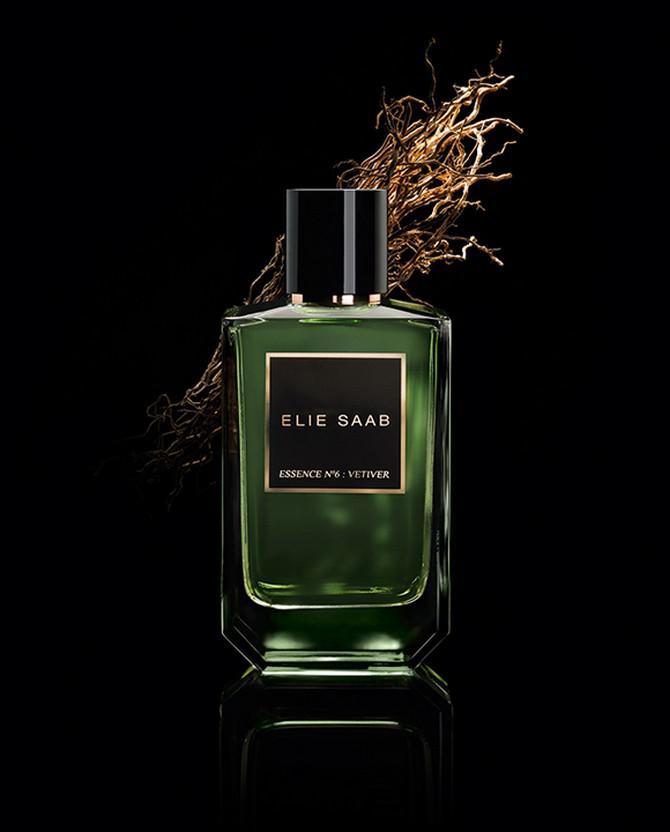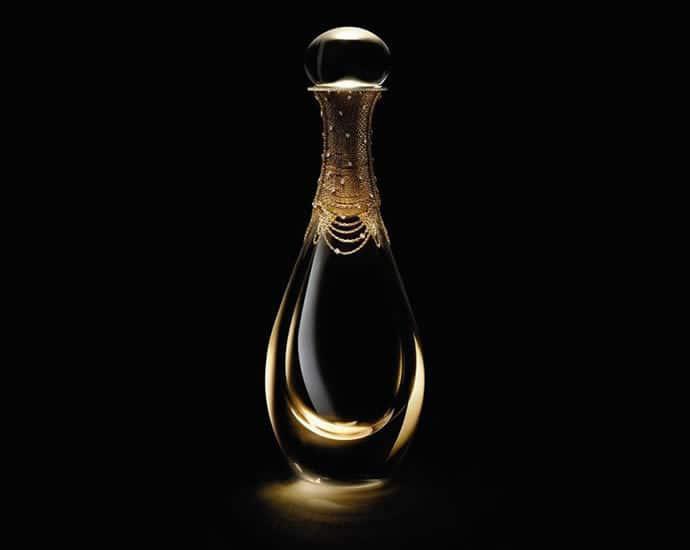The first image is the image on the left, the second image is the image on the right. For the images shown, is this caption "There are more than two perfume bottles." true? Answer yes or no. No. The first image is the image on the left, the second image is the image on the right. Examine the images to the left and right. Is the description "An image includes a fragrance bottle with a rounded base ad round cap." accurate? Answer yes or no. Yes. 